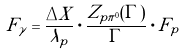Convert formula to latex. <formula><loc_0><loc_0><loc_500><loc_500>F _ { \gamma } = \frac { \Delta X } { \lambda _ { p } } \cdot \frac { Z _ { p \pi ^ { 0 } } ( \Gamma ) } { \Gamma } \cdot F _ { p }</formula> 